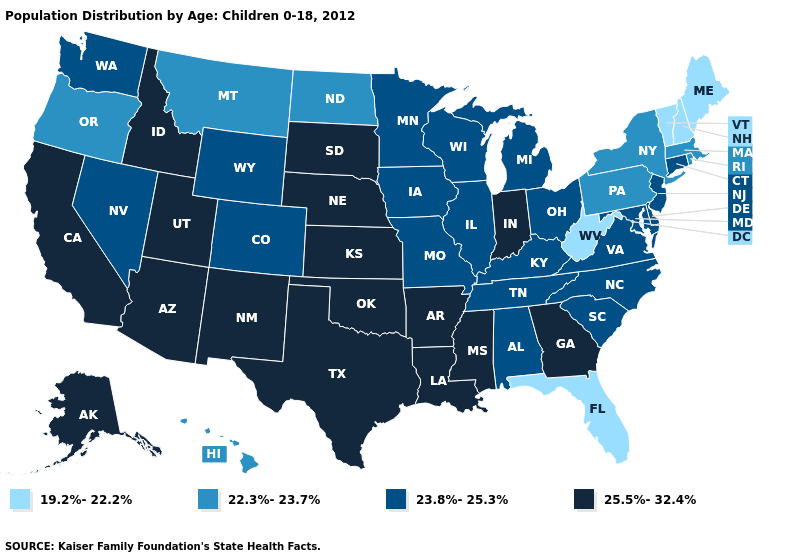Name the states that have a value in the range 23.8%-25.3%?
Keep it brief. Alabama, Colorado, Connecticut, Delaware, Illinois, Iowa, Kentucky, Maryland, Michigan, Minnesota, Missouri, Nevada, New Jersey, North Carolina, Ohio, South Carolina, Tennessee, Virginia, Washington, Wisconsin, Wyoming. Which states have the highest value in the USA?
Give a very brief answer. Alaska, Arizona, Arkansas, California, Georgia, Idaho, Indiana, Kansas, Louisiana, Mississippi, Nebraska, New Mexico, Oklahoma, South Dakota, Texas, Utah. What is the value of Vermont?
Quick response, please. 19.2%-22.2%. Does the first symbol in the legend represent the smallest category?
Concise answer only. Yes. What is the value of Florida?
Concise answer only. 19.2%-22.2%. What is the value of Alaska?
Write a very short answer. 25.5%-32.4%. Name the states that have a value in the range 22.3%-23.7%?
Write a very short answer. Hawaii, Massachusetts, Montana, New York, North Dakota, Oregon, Pennsylvania, Rhode Island. Does New Mexico have the highest value in the USA?
Write a very short answer. Yes. What is the highest value in states that border Indiana?
Short answer required. 23.8%-25.3%. What is the value of Virginia?
Concise answer only. 23.8%-25.3%. Which states have the highest value in the USA?
Short answer required. Alaska, Arizona, Arkansas, California, Georgia, Idaho, Indiana, Kansas, Louisiana, Mississippi, Nebraska, New Mexico, Oklahoma, South Dakota, Texas, Utah. Name the states that have a value in the range 19.2%-22.2%?
Concise answer only. Florida, Maine, New Hampshire, Vermont, West Virginia. Which states have the lowest value in the West?
Give a very brief answer. Hawaii, Montana, Oregon. Name the states that have a value in the range 25.5%-32.4%?
Be succinct. Alaska, Arizona, Arkansas, California, Georgia, Idaho, Indiana, Kansas, Louisiana, Mississippi, Nebraska, New Mexico, Oklahoma, South Dakota, Texas, Utah. Name the states that have a value in the range 19.2%-22.2%?
Answer briefly. Florida, Maine, New Hampshire, Vermont, West Virginia. 